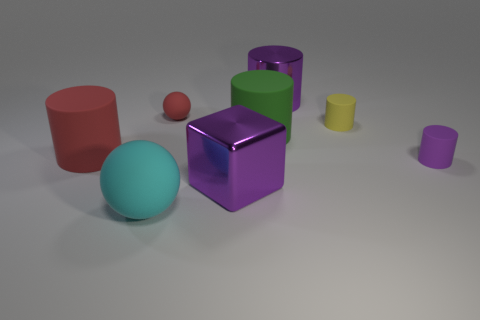There is a large green object; what number of big cylinders are behind it?
Provide a succinct answer. 1. There is a big metallic object that is the same shape as the green matte thing; what is its color?
Your answer should be compact. Purple. The cylinder that is both to the left of the tiny yellow matte object and behind the green rubber cylinder is made of what material?
Offer a very short reply. Metal. Does the object that is on the right side of the yellow matte thing have the same size as the tiny red ball?
Ensure brevity in your answer.  Yes. What is the material of the big purple cylinder?
Ensure brevity in your answer.  Metal. There is a shiny thing in front of the yellow rubber cylinder; what is its color?
Keep it short and to the point. Purple. How many big objects are red matte cylinders or purple shiny cubes?
Give a very brief answer. 2. There is a big metal object to the left of the large purple cylinder; does it have the same color as the big cylinder that is to the left of the small ball?
Your answer should be very brief. No. How many other objects are there of the same color as the big sphere?
Keep it short and to the point. 0. How many gray objects are either small objects or small matte balls?
Your response must be concise. 0. 